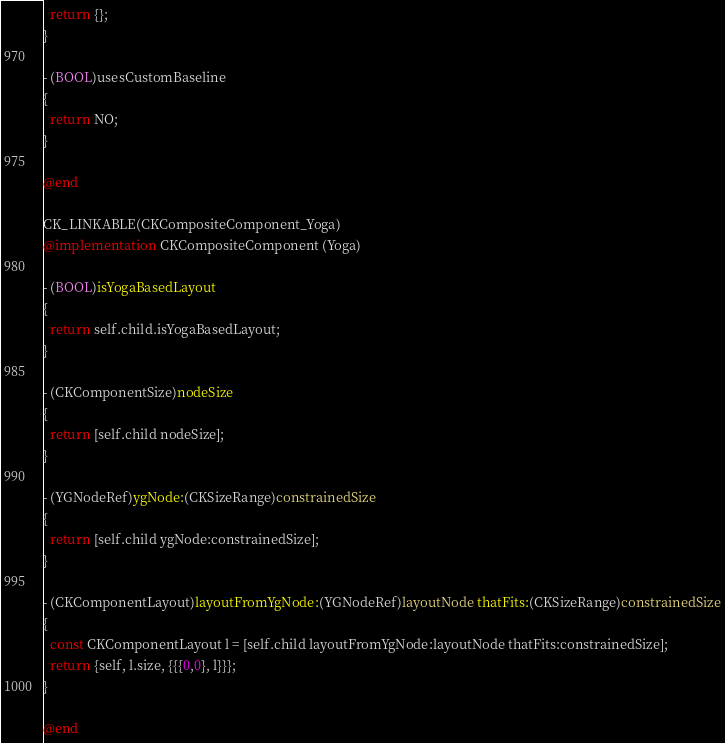Convert code to text. <code><loc_0><loc_0><loc_500><loc_500><_ObjectiveC_>  return {};
}

- (BOOL)usesCustomBaseline
{
  return NO;
}

@end

CK_LINKABLE(CKCompositeComponent_Yoga)
@implementation CKCompositeComponent (Yoga)

- (BOOL)isYogaBasedLayout
{
  return self.child.isYogaBasedLayout;
}

- (CKComponentSize)nodeSize
{
  return [self.child nodeSize];
}

- (YGNodeRef)ygNode:(CKSizeRange)constrainedSize
{
  return [self.child ygNode:constrainedSize];
}

- (CKComponentLayout)layoutFromYgNode:(YGNodeRef)layoutNode thatFits:(CKSizeRange)constrainedSize
{
  const CKComponentLayout l = [self.child layoutFromYgNode:layoutNode thatFits:constrainedSize];
  return {self, l.size, {{{0,0}, l}}};
}

@end
</code> 